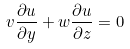Convert formula to latex. <formula><loc_0><loc_0><loc_500><loc_500>v \frac { \partial u } { \partial y } + w \frac { \partial u } { \partial z } = 0</formula> 